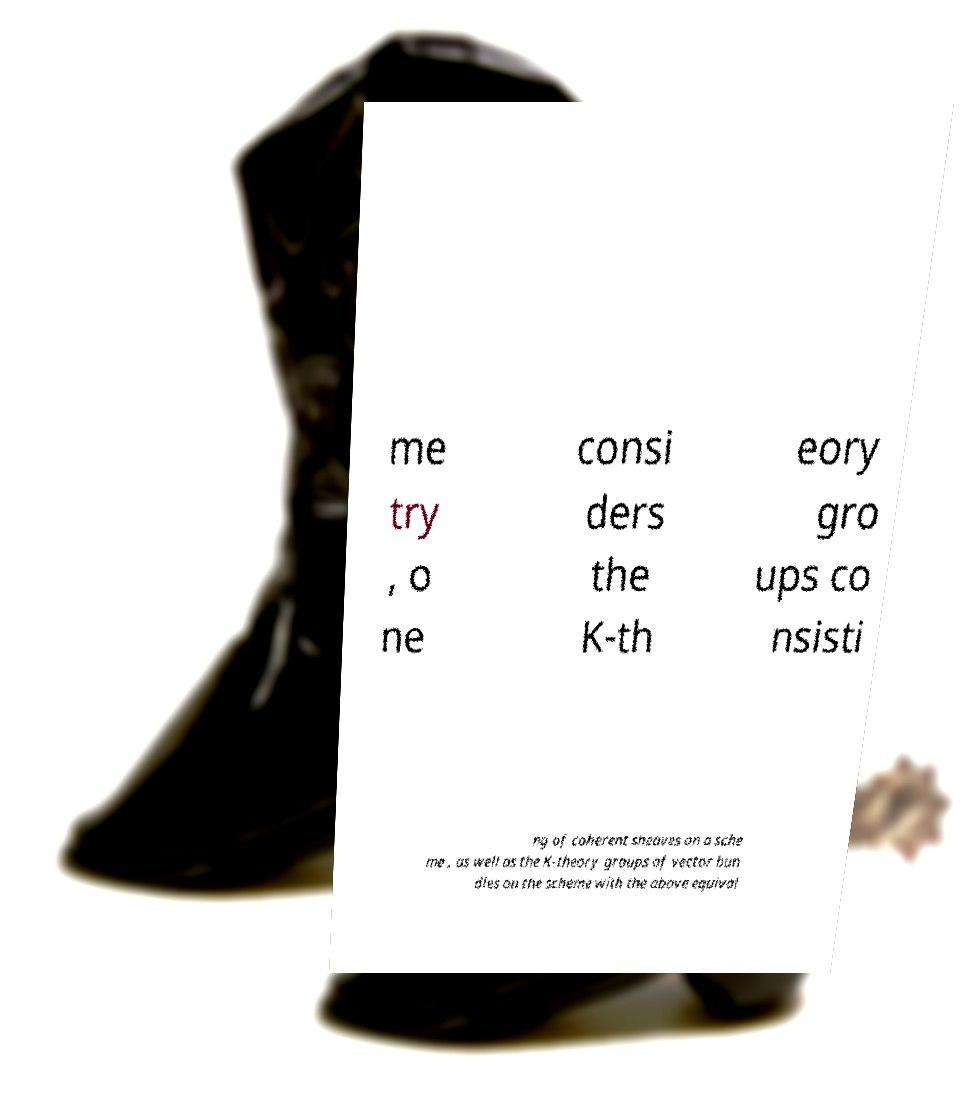I need the written content from this picture converted into text. Can you do that? me try , o ne consi ders the K-th eory gro ups co nsisti ng of coherent sheaves on a sche me , as well as the K-theory groups of vector bun dles on the scheme with the above equival 